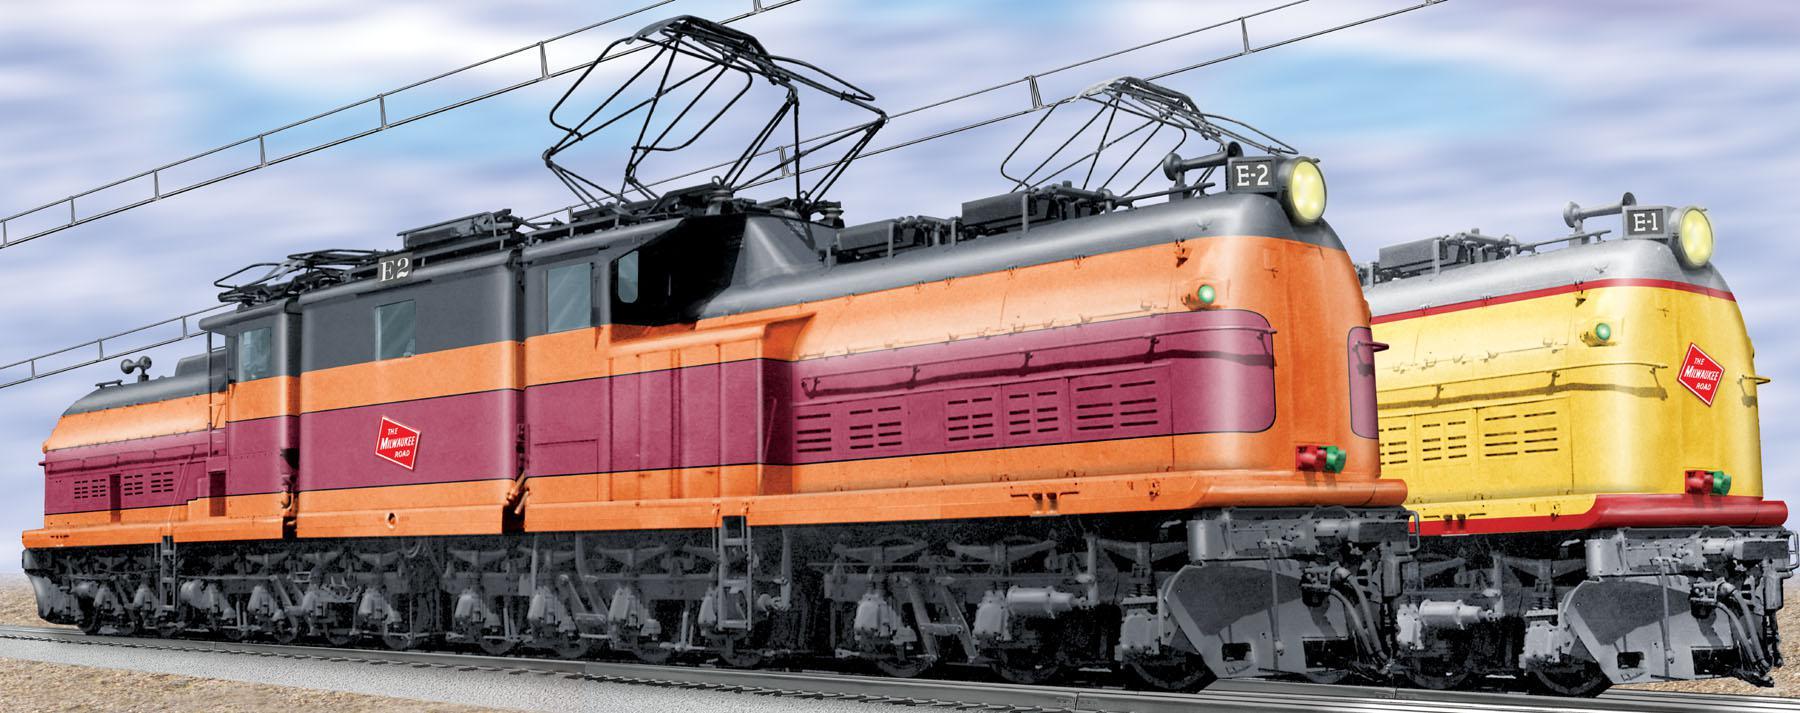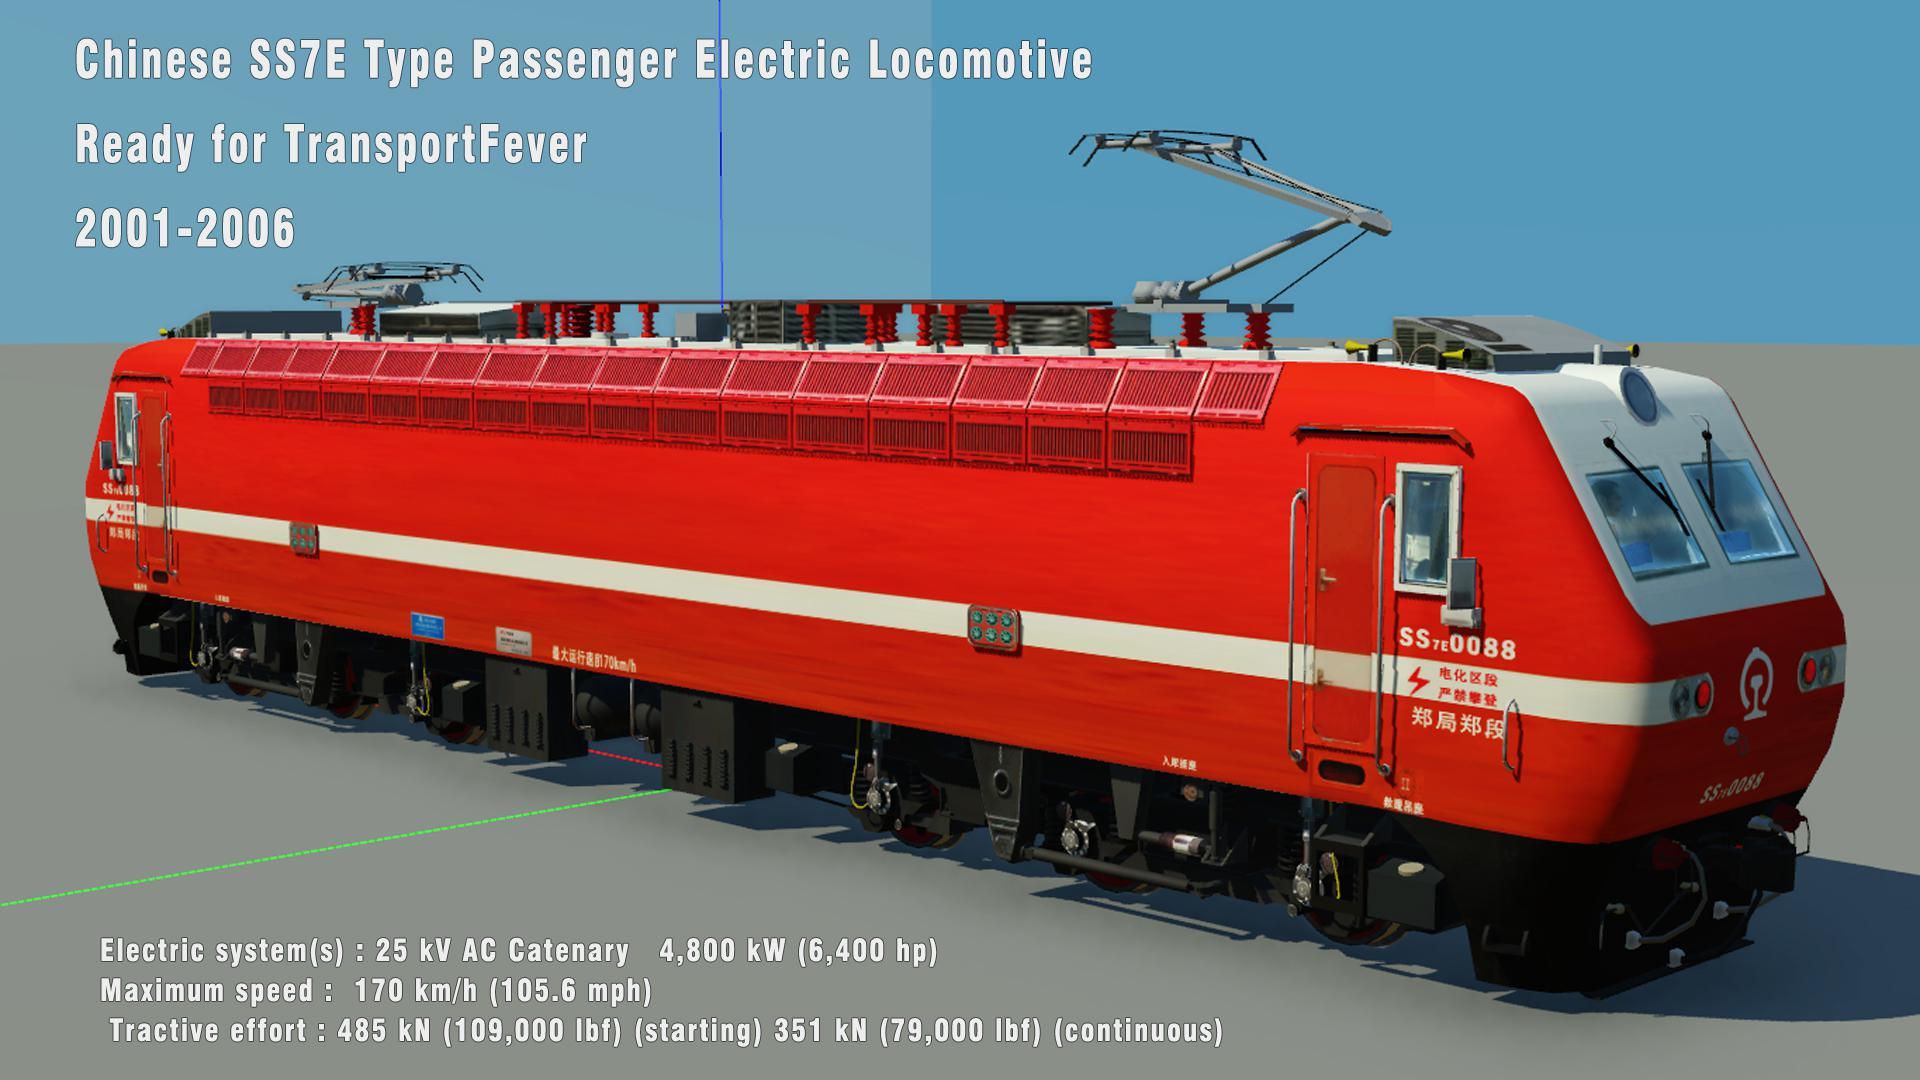The first image is the image on the left, the second image is the image on the right. Given the left and right images, does the statement "The right image contains a train that is predominately blue." hold true? Answer yes or no. No. The first image is the image on the left, the second image is the image on the right. Analyze the images presented: Is the assertion "The trains in the left and right images do not head in the same left or right direction, and at least one train is blue with a sloped front." valid? Answer yes or no. No. 